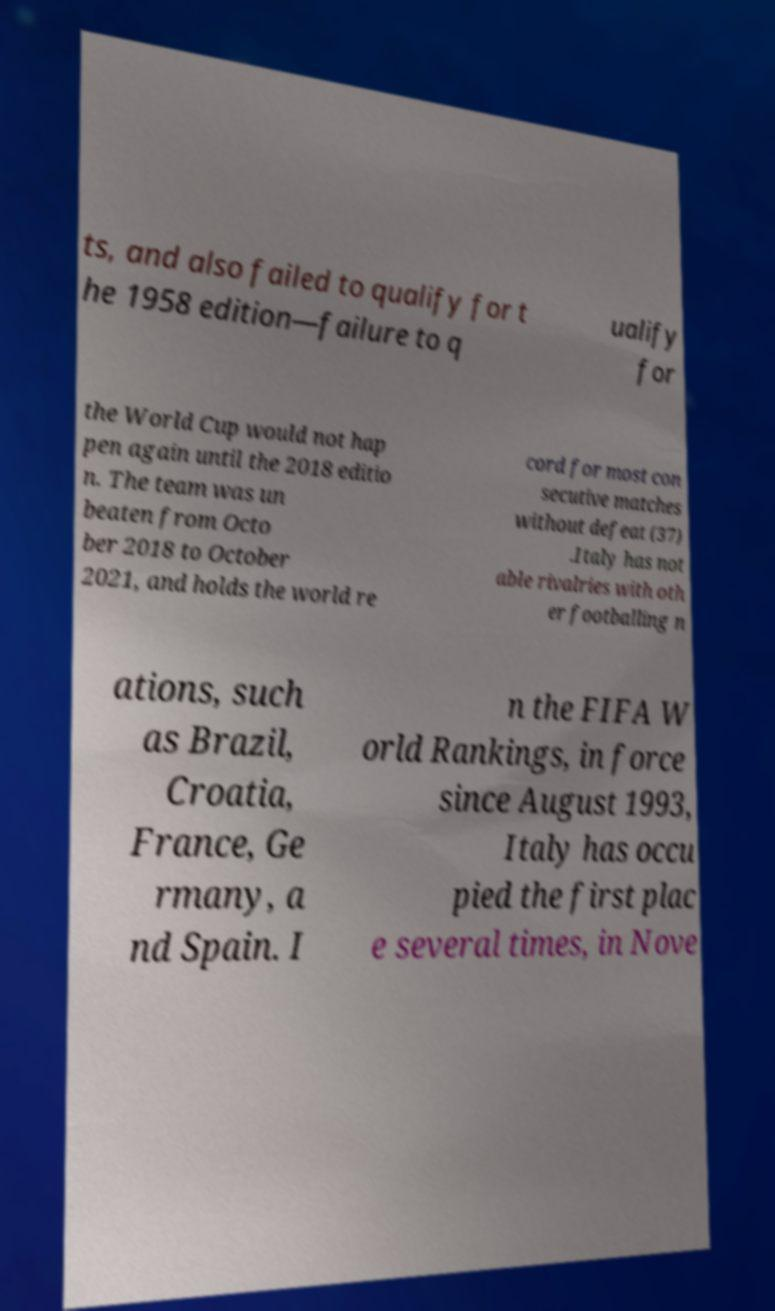I need the written content from this picture converted into text. Can you do that? ts, and also failed to qualify for t he 1958 edition—failure to q ualify for the World Cup would not hap pen again until the 2018 editio n. The team was un beaten from Octo ber 2018 to October 2021, and holds the world re cord for most con secutive matches without defeat (37) .Italy has not able rivalries with oth er footballing n ations, such as Brazil, Croatia, France, Ge rmany, a nd Spain. I n the FIFA W orld Rankings, in force since August 1993, Italy has occu pied the first plac e several times, in Nove 